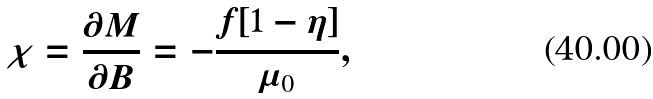<formula> <loc_0><loc_0><loc_500><loc_500>\chi = \frac { \partial M } { \partial B } = - \frac { f [ 1 - \eta ] } { \mu _ { 0 } } ,</formula> 